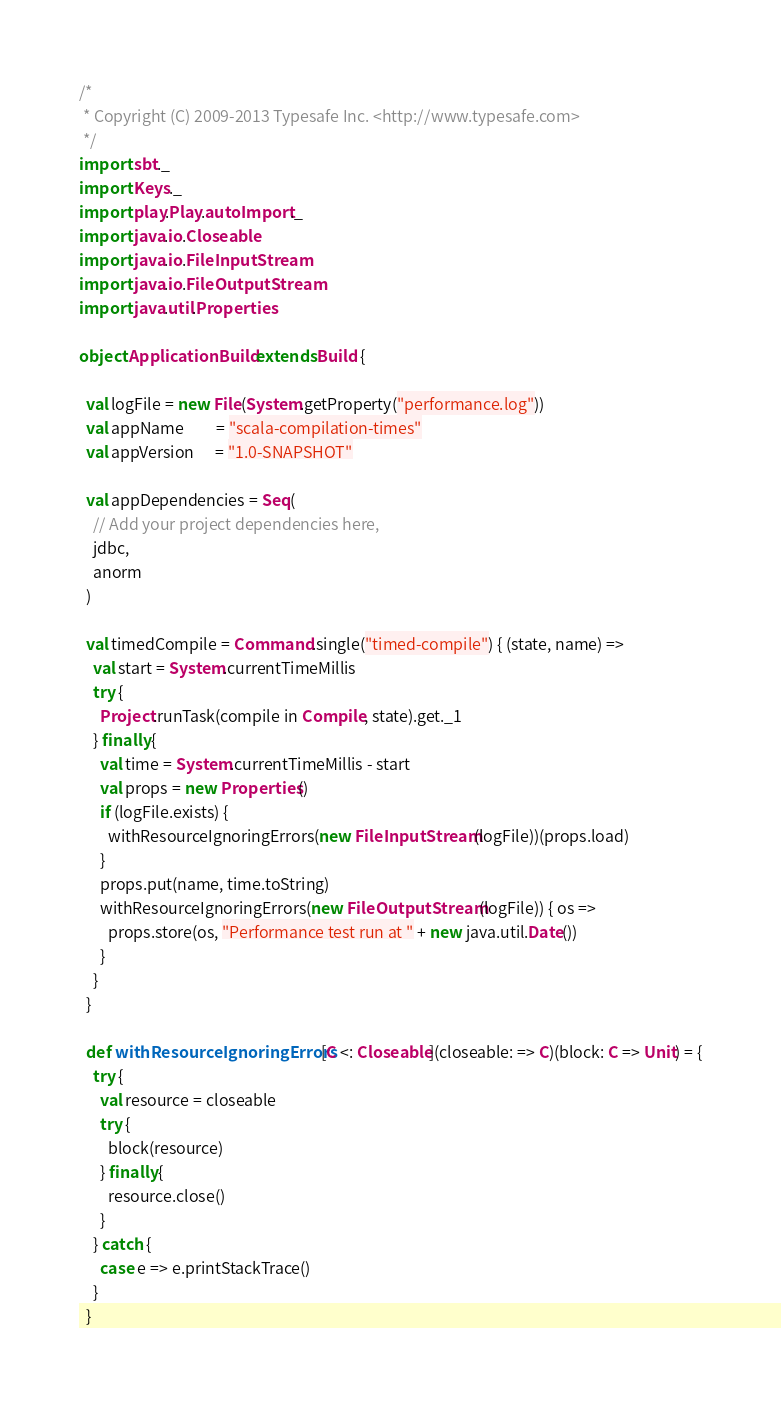<code> <loc_0><loc_0><loc_500><loc_500><_Scala_>/*
 * Copyright (C) 2009-2013 Typesafe Inc. <http://www.typesafe.com>
 */
import sbt._
import Keys._
import play.Play.autoImport._
import java.io.Closeable
import java.io.FileInputStream
import java.io.FileOutputStream
import java.util.Properties

object ApplicationBuild extends Build {

  val logFile = new File(System.getProperty("performance.log"))
  val appName         = "scala-compilation-times"
  val appVersion      = "1.0-SNAPSHOT"

  val appDependencies = Seq(
    // Add your project dependencies here,
    jdbc,
    anorm
  )

  val timedCompile = Command.single("timed-compile") { (state, name) => 
    val start = System.currentTimeMillis
    try {
      Project.runTask(compile in Compile, state).get._1
    } finally {
      val time = System.currentTimeMillis - start
      val props = new Properties()
      if (logFile.exists) {
        withResourceIgnoringErrors(new FileInputStream(logFile))(props.load)
      }
      props.put(name, time.toString)
      withResourceIgnoringErrors(new FileOutputStream(logFile)) { os =>
        props.store(os, "Performance test run at " + new java.util.Date())
      }
    }
  }

  def withResourceIgnoringErrors[C <: Closeable](closeable: => C)(block: C => Unit) = {
    try {
      val resource = closeable
      try {
        block(resource)
      } finally {
        resource.close()
      }
    } catch {
      case e => e.printStackTrace()
    }
  }
</code> 